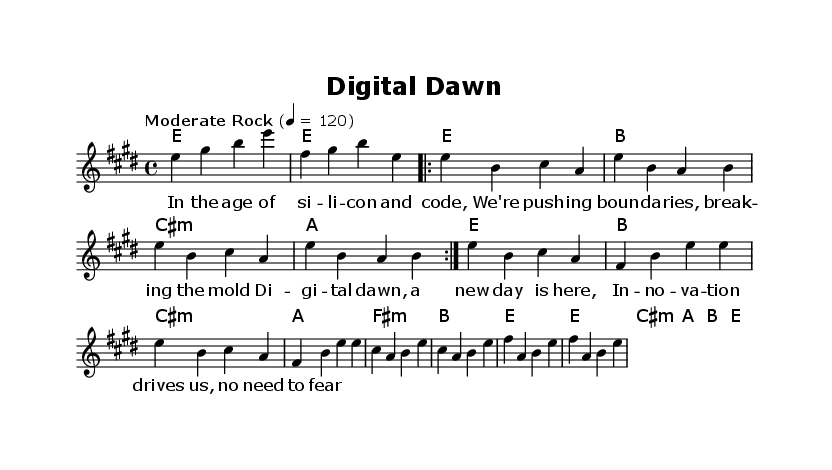What is the key signature of this music? The key signature is indicated by the number of sharps or flats at the beginning of the staff. In this sheet music, there are four sharps which corresponds to E major.
Answer: E major What is the time signature of this music? The time signature is found at the beginning of the sheet music, immediately following the clef symbol. Here, it is represented as 4/4, which is common time.
Answer: 4/4 What is the tempo marking of this music? The tempo marking is indicated in the tempo section, where a specific musical term is provided. In this case, it shows "Moderate Rock" with a metronome marking of 120.
Answer: Moderate Rock How many measures are in the Chorus section of the music? To determine this, we must count each bar in the Chorus part specifically. The Chorus is indicated and consists of four measures.
Answer: 4 What is the first lyric of the verse? The first lyric of the verse is positioned directly beneath the corresponding notes of the melody. The first word seen in the lyric section is "In".
Answer: In How do the melody and harmonies relate in this piece? The melody is played by the lead voice and is often supported by chordal harmonies below it. In this piece, chords are played that generally harmonize with each note of the melody line, creating a full sound characteristic of rock anthems.
Answer: Harmonized What is the mood conveyed in the lyrics of this composition? To ascertain the mood, we analyze the content and themes present in the lyrics. The lyrics speak about innovation and courage in the face of change, which conveys a positive and empowering sentiment.
Answer: Empowering 